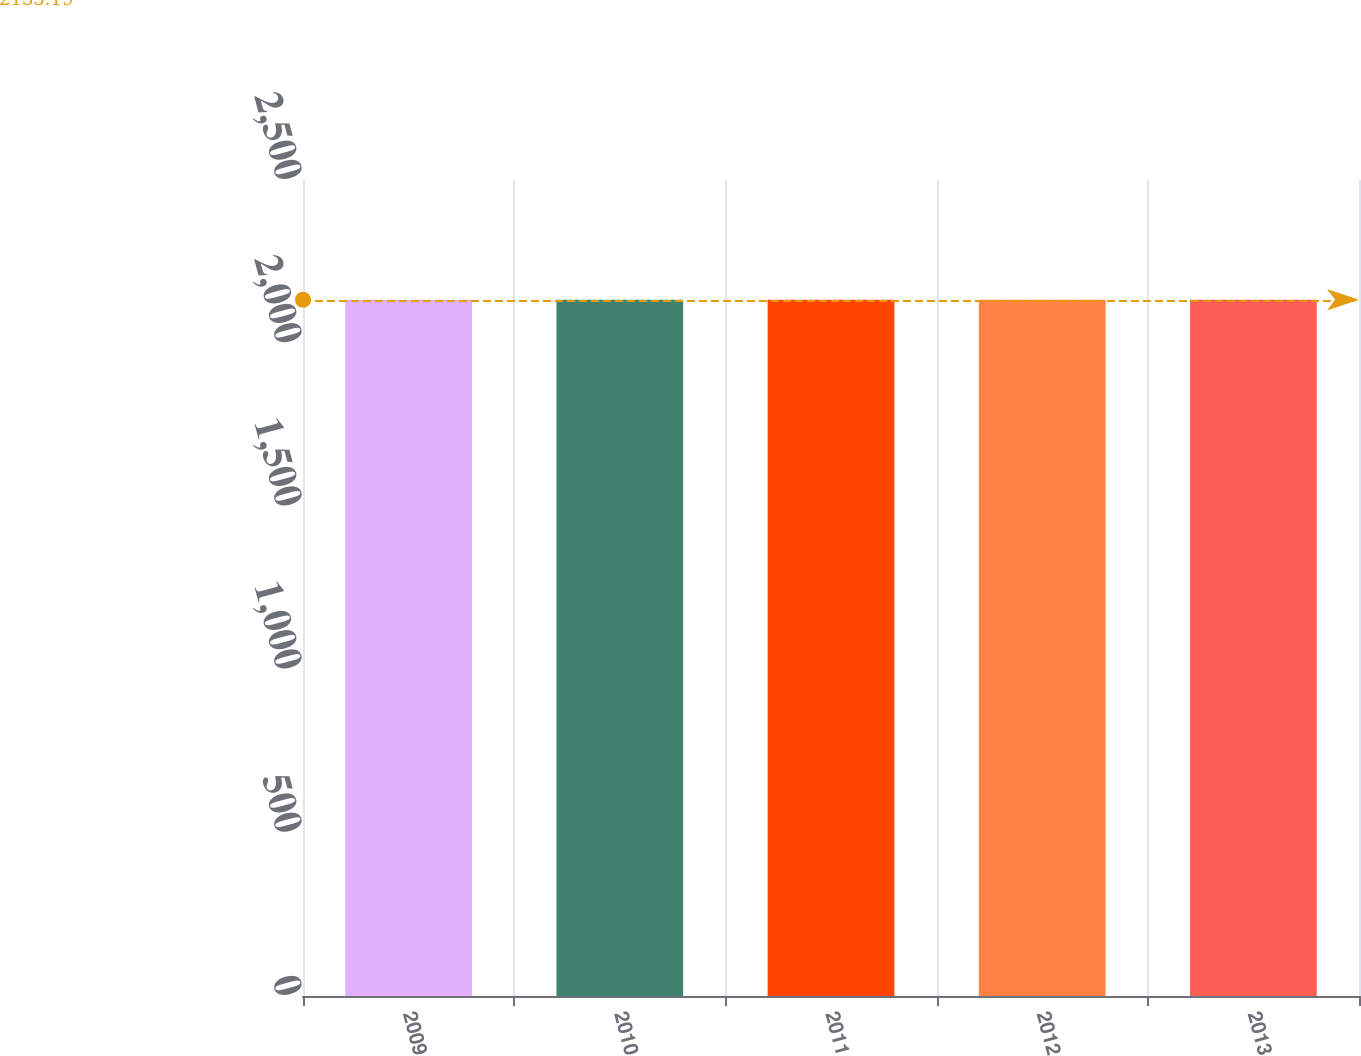Convert chart. <chart><loc_0><loc_0><loc_500><loc_500><bar_chart><fcel>2009<fcel>2010<fcel>2011<fcel>2012<fcel>2013<nl><fcel>2133<fcel>2133.1<fcel>2133.2<fcel>2133.3<fcel>2133.4<nl></chart> 